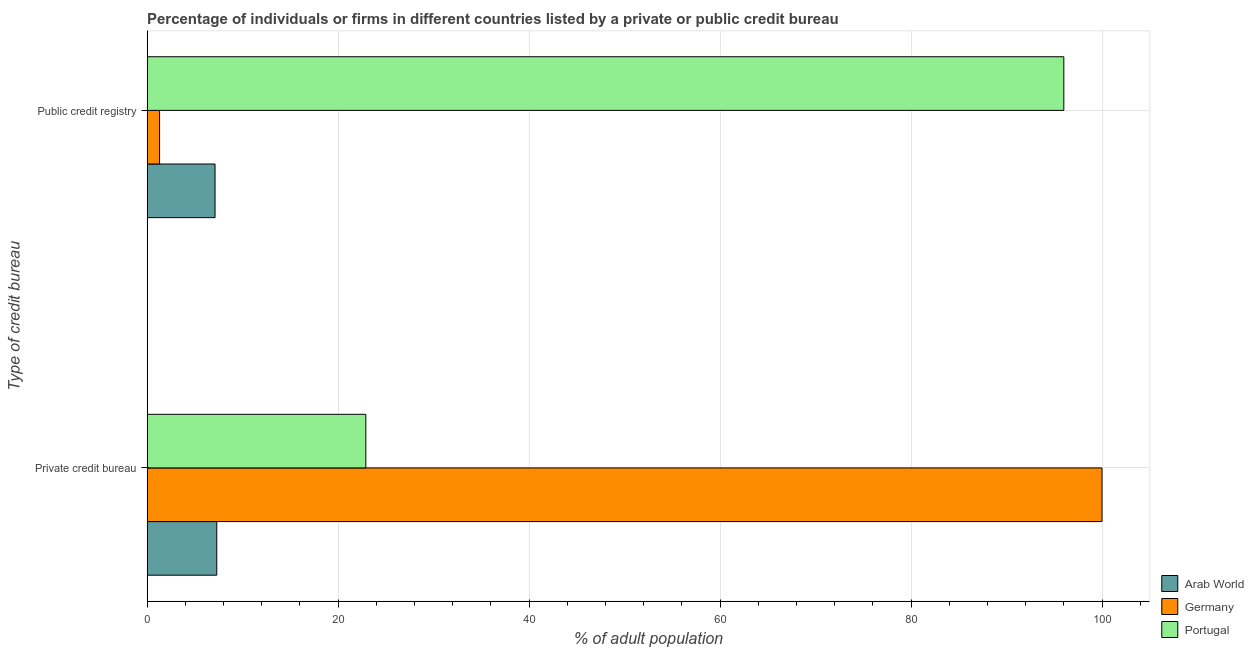How many different coloured bars are there?
Provide a succinct answer. 3. How many groups of bars are there?
Offer a terse response. 2. Are the number of bars on each tick of the Y-axis equal?
Offer a terse response. Yes. What is the label of the 1st group of bars from the top?
Your answer should be very brief. Public credit registry. Across all countries, what is the maximum percentage of firms listed by public credit bureau?
Offer a very short reply. 96. Across all countries, what is the minimum percentage of firms listed by public credit bureau?
Your answer should be compact. 1.3. In which country was the percentage of firms listed by private credit bureau minimum?
Your answer should be compact. Arab World. What is the total percentage of firms listed by private credit bureau in the graph?
Ensure brevity in your answer.  130.19. What is the difference between the percentage of firms listed by private credit bureau in Arab World and that in Portugal?
Provide a short and direct response. -15.61. What is the difference between the percentage of firms listed by public credit bureau in Germany and the percentage of firms listed by private credit bureau in Portugal?
Your answer should be compact. -21.6. What is the average percentage of firms listed by private credit bureau per country?
Provide a short and direct response. 43.4. What is the difference between the percentage of firms listed by private credit bureau and percentage of firms listed by public credit bureau in Arab World?
Provide a short and direct response. 0.18. In how many countries, is the percentage of firms listed by private credit bureau greater than 76 %?
Give a very brief answer. 1. What is the ratio of the percentage of firms listed by public credit bureau in Portugal to that in Arab World?
Make the answer very short. 13.5. What does the 3rd bar from the top in Public credit registry represents?
Give a very brief answer. Arab World. What does the 1st bar from the bottom in Private credit bureau represents?
Provide a succinct answer. Arab World. How many bars are there?
Offer a very short reply. 6. What is the difference between two consecutive major ticks on the X-axis?
Keep it short and to the point. 20. Are the values on the major ticks of X-axis written in scientific E-notation?
Provide a short and direct response. No. Does the graph contain any zero values?
Offer a very short reply. No. What is the title of the graph?
Your answer should be very brief. Percentage of individuals or firms in different countries listed by a private or public credit bureau. What is the label or title of the X-axis?
Keep it short and to the point. % of adult population. What is the label or title of the Y-axis?
Your answer should be compact. Type of credit bureau. What is the % of adult population in Arab World in Private credit bureau?
Ensure brevity in your answer.  7.29. What is the % of adult population in Portugal in Private credit bureau?
Your answer should be compact. 22.9. What is the % of adult population of Arab World in Public credit registry?
Provide a succinct answer. 7.11. What is the % of adult population in Portugal in Public credit registry?
Offer a very short reply. 96. Across all Type of credit bureau, what is the maximum % of adult population of Arab World?
Your answer should be compact. 7.29. Across all Type of credit bureau, what is the maximum % of adult population in Portugal?
Your answer should be compact. 96. Across all Type of credit bureau, what is the minimum % of adult population of Arab World?
Your response must be concise. 7.11. Across all Type of credit bureau, what is the minimum % of adult population in Germany?
Provide a succinct answer. 1.3. Across all Type of credit bureau, what is the minimum % of adult population of Portugal?
Provide a short and direct response. 22.9. What is the total % of adult population in Germany in the graph?
Offer a very short reply. 101.3. What is the total % of adult population in Portugal in the graph?
Keep it short and to the point. 118.9. What is the difference between the % of adult population in Arab World in Private credit bureau and that in Public credit registry?
Your answer should be very brief. 0.18. What is the difference between the % of adult population in Germany in Private credit bureau and that in Public credit registry?
Make the answer very short. 98.7. What is the difference between the % of adult population in Portugal in Private credit bureau and that in Public credit registry?
Keep it short and to the point. -73.1. What is the difference between the % of adult population of Arab World in Private credit bureau and the % of adult population of Germany in Public credit registry?
Your response must be concise. 5.99. What is the difference between the % of adult population in Arab World in Private credit bureau and the % of adult population in Portugal in Public credit registry?
Give a very brief answer. -88.71. What is the average % of adult population in Germany per Type of credit bureau?
Provide a short and direct response. 50.65. What is the average % of adult population of Portugal per Type of credit bureau?
Make the answer very short. 59.45. What is the difference between the % of adult population in Arab World and % of adult population in Germany in Private credit bureau?
Give a very brief answer. -92.71. What is the difference between the % of adult population of Arab World and % of adult population of Portugal in Private credit bureau?
Ensure brevity in your answer.  -15.61. What is the difference between the % of adult population of Germany and % of adult population of Portugal in Private credit bureau?
Your response must be concise. 77.1. What is the difference between the % of adult population of Arab World and % of adult population of Germany in Public credit registry?
Make the answer very short. 5.81. What is the difference between the % of adult population of Arab World and % of adult population of Portugal in Public credit registry?
Offer a very short reply. -88.89. What is the difference between the % of adult population of Germany and % of adult population of Portugal in Public credit registry?
Provide a short and direct response. -94.7. What is the ratio of the % of adult population of Arab World in Private credit bureau to that in Public credit registry?
Keep it short and to the point. 1.03. What is the ratio of the % of adult population of Germany in Private credit bureau to that in Public credit registry?
Give a very brief answer. 76.92. What is the ratio of the % of adult population in Portugal in Private credit bureau to that in Public credit registry?
Provide a short and direct response. 0.24. What is the difference between the highest and the second highest % of adult population in Arab World?
Keep it short and to the point. 0.18. What is the difference between the highest and the second highest % of adult population of Germany?
Offer a terse response. 98.7. What is the difference between the highest and the second highest % of adult population in Portugal?
Offer a very short reply. 73.1. What is the difference between the highest and the lowest % of adult population of Arab World?
Provide a short and direct response. 0.18. What is the difference between the highest and the lowest % of adult population of Germany?
Your answer should be very brief. 98.7. What is the difference between the highest and the lowest % of adult population in Portugal?
Your response must be concise. 73.1. 